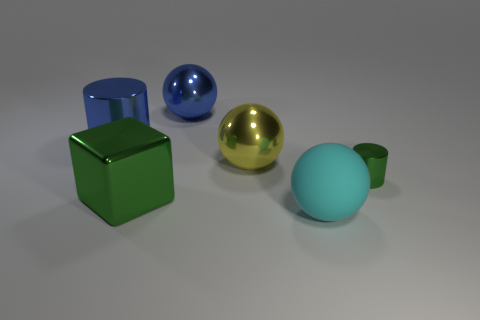Add 1 metallic cylinders. How many objects exist? 7 Subtract all cylinders. How many objects are left? 4 Subtract 1 cyan balls. How many objects are left? 5 Subtract all small brown rubber things. Subtract all big metal cylinders. How many objects are left? 5 Add 2 blue metallic spheres. How many blue metallic spheres are left? 3 Add 1 big metal cubes. How many big metal cubes exist? 2 